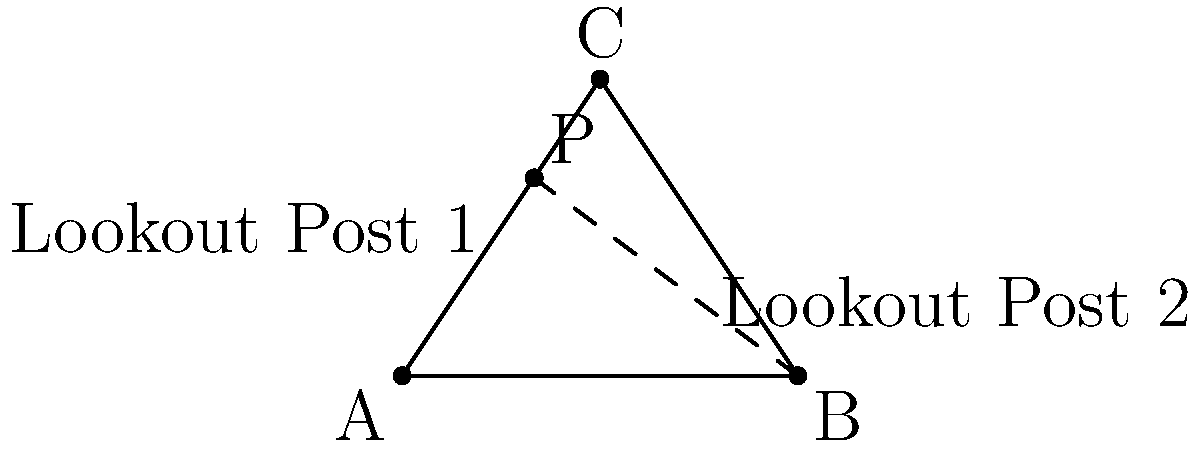During a Civil War battle, two lookout posts need to be positioned to monitor enemy movements. Post 1 is located on a line between points A(0,0) and C(4,6), while Post 2 is on a line between B(8,0) and a point (4,3). If the optimal position is where these lines intersect, what are the coordinates of point P where the lookout posts should be placed for maximum effectiveness? To find the intersection point P, we need to follow these steps:

1. Find the equations of both lines:
   Line AC: $y = \frac{6}{4}x = \frac{3}{2}x$
   Line from B to (4,3): $y = -\frac{3}{4}x + 6$

2. Set the equations equal to each other to find the x-coordinate of P:
   $\frac{3}{2}x = -\frac{3}{4}x + 6$
   $\frac{9}{4}x = 6$
   $x = \frac{24}{9} = \frac{8}{3}$

3. Substitute this x-value into either equation to find the y-coordinate:
   $y = \frac{3}{2} \cdot \frac{8}{3} = 4$

4. Therefore, the coordinates of point P are $(\frac{8}{3}, 4)$ or approximately (2.67, 4).

This point represents the optimal position for the lookout posts, providing the best vantage point to monitor enemy movements during the battle.
Answer: $P(\frac{8}{3}, 4)$ 